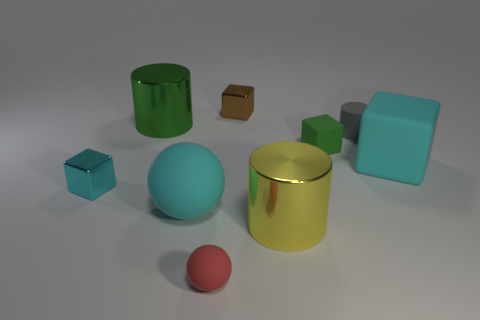Subtract all blocks. How many objects are left? 5 Add 6 large yellow metal objects. How many large yellow metal objects are left? 7 Add 3 large green cylinders. How many large green cylinders exist? 4 Subtract 0 blue blocks. How many objects are left? 9 Subtract all tiny cubes. Subtract all large matte things. How many objects are left? 4 